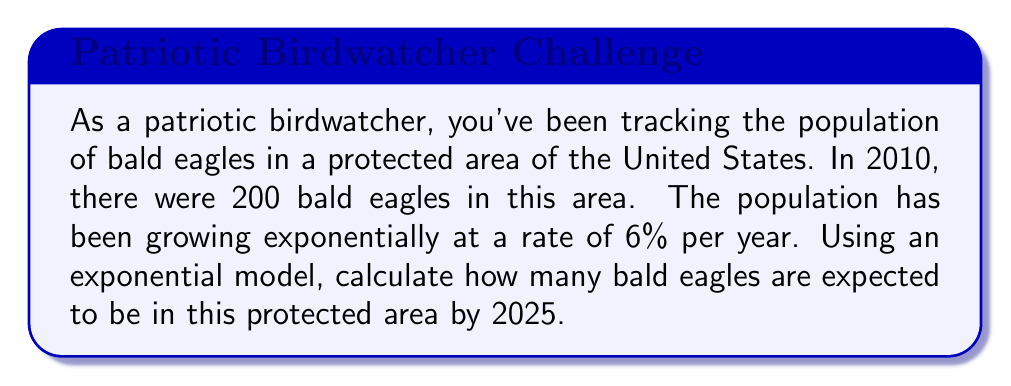Could you help me with this problem? To solve this problem, we'll use the exponential growth model:

$$A = P(1 + r)^t$$

Where:
$A$ = Final amount (population in 2025)
$P$ = Initial amount (population in 2010)
$r$ = Growth rate (as a decimal)
$t$ = Time period (in years)

Given:
$P = 200$ (initial population in 2010)
$r = 0.06$ (6% growth rate expressed as a decimal)
$t = 15$ (number of years from 2010 to 2025)

Let's substitute these values into the formula:

$$A = 200(1 + 0.06)^{15}$$

Now, let's calculate step-by-step:

1) First, calculate $(1 + 0.06)$:
   $1 + 0.06 = 1.06$

2) Now, we have:
   $$A = 200(1.06)^{15}$$

3) Calculate $(1.06)^{15}$:
   $(1.06)^{15} \approx 2.3966$ (rounded to 4 decimal places)

4) Finally, multiply by 200:
   $$A = 200 \times 2.3966 = 479.32$$

5) Since we're dealing with whole eagles, we round to the nearest integer:
   $$A \approx 479$$
Answer: By 2025, there are expected to be approximately 479 bald eagles in the protected area. 